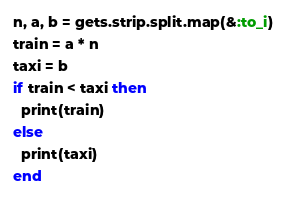Convert code to text. <code><loc_0><loc_0><loc_500><loc_500><_Ruby_>n, a, b = gets.strip.split.map(&:to_i)
train = a * n
taxi = b
if train < taxi then
  print(train)
else
  print(taxi)
end</code> 